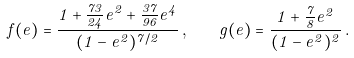<formula> <loc_0><loc_0><loc_500><loc_500>f ( e ) = \frac { 1 + \frac { 7 3 } { 2 4 } e ^ { 2 } + \frac { 3 7 } { 9 6 } e ^ { 4 } } { ( 1 - e ^ { 2 } ) ^ { 7 / 2 } } \, , \quad g ( e ) = \frac { 1 + \frac { 7 } { 8 } e ^ { 2 } } { ( 1 - e ^ { 2 } ) ^ { 2 } } \, .</formula> 